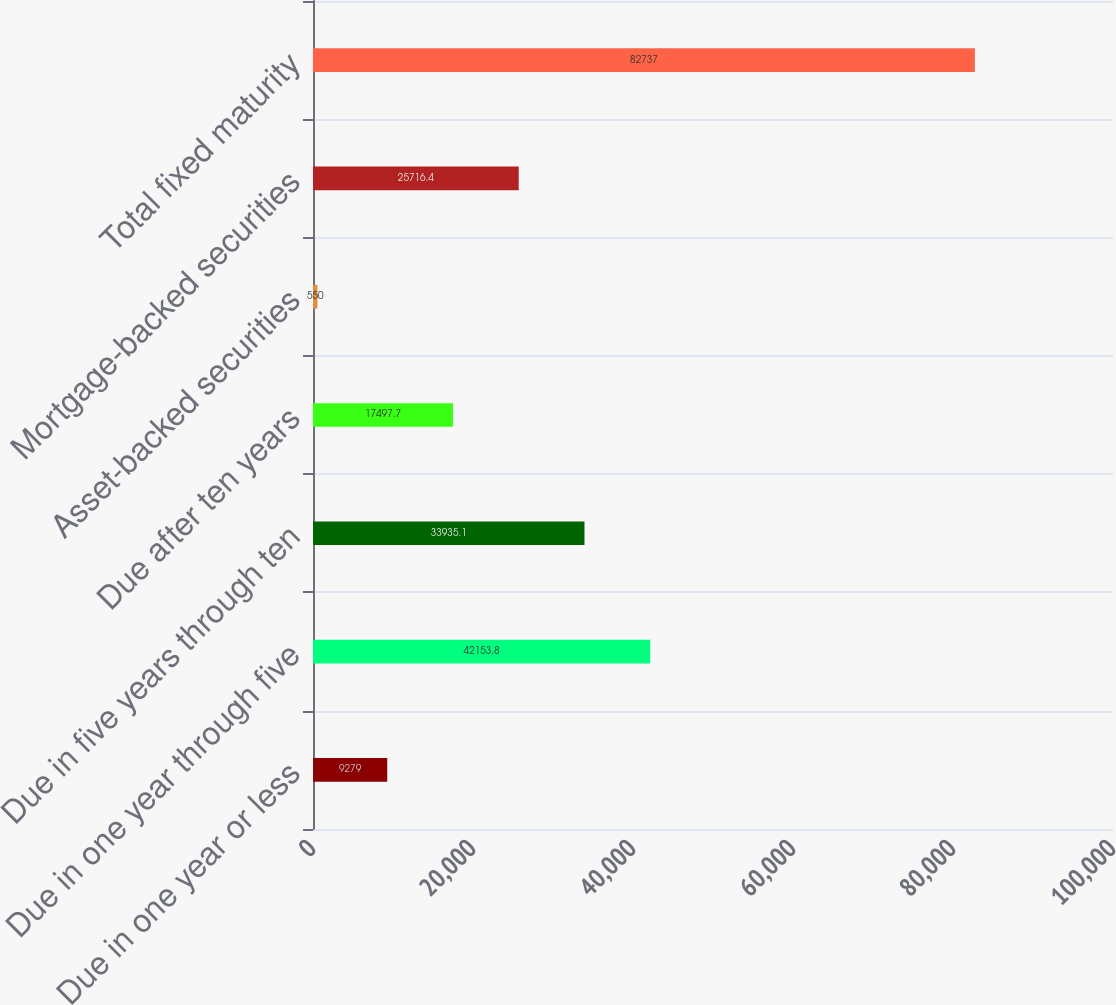Convert chart. <chart><loc_0><loc_0><loc_500><loc_500><bar_chart><fcel>Due in one year or less<fcel>Due in one year through five<fcel>Due in five years through ten<fcel>Due after ten years<fcel>Asset-backed securities<fcel>Mortgage-backed securities<fcel>Total fixed maturity<nl><fcel>9279<fcel>42153.8<fcel>33935.1<fcel>17497.7<fcel>550<fcel>25716.4<fcel>82737<nl></chart> 